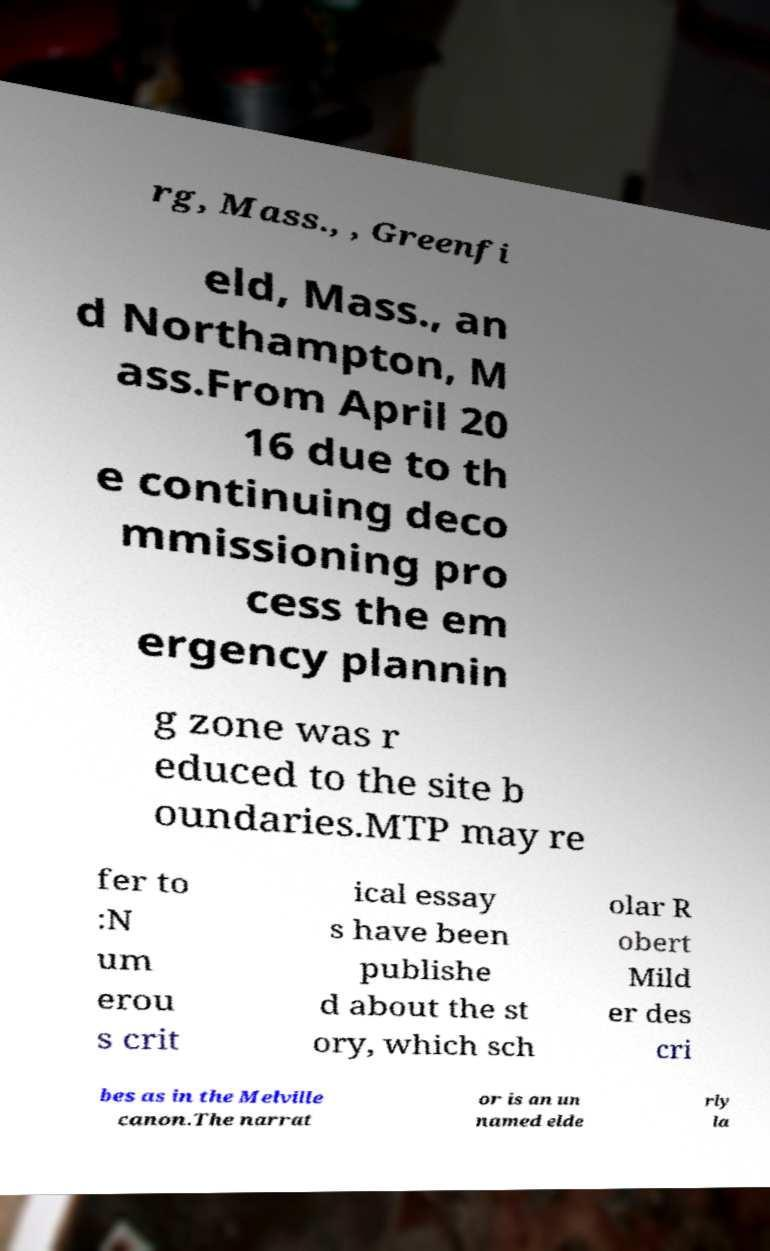I need the written content from this picture converted into text. Can you do that? rg, Mass., , Greenfi eld, Mass., an d Northampton, M ass.From April 20 16 due to th e continuing deco mmissioning pro cess the em ergency plannin g zone was r educed to the site b oundaries.MTP may re fer to :N um erou s crit ical essay s have been publishe d about the st ory, which sch olar R obert Mild er des cri bes as in the Melville canon.The narrat or is an un named elde rly la 